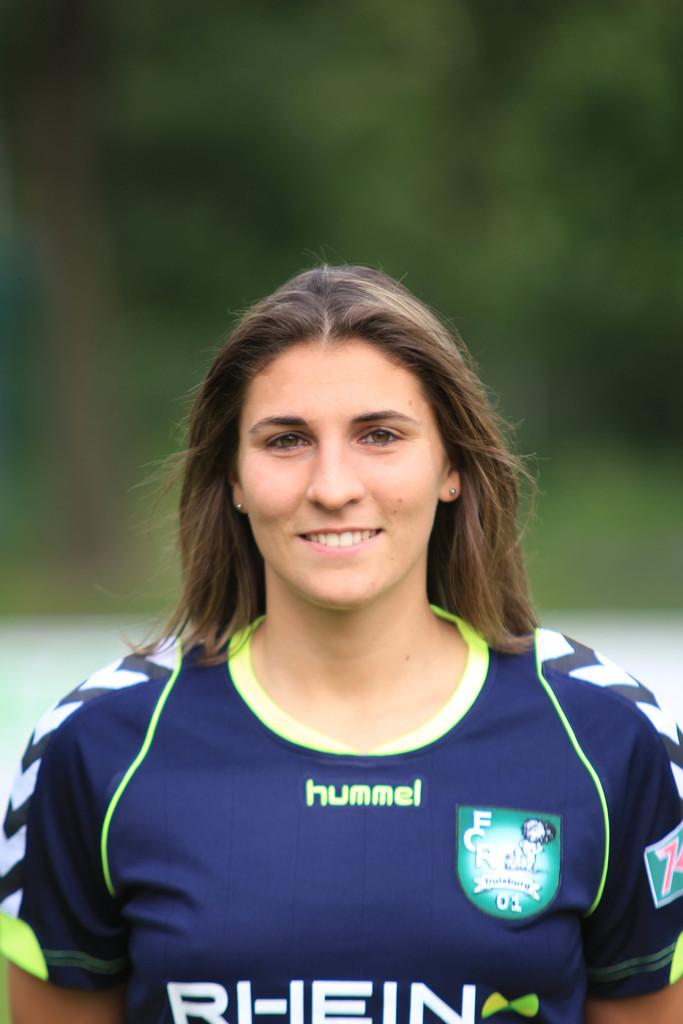Provide a one-sentence caption for the provided image. Woman is wearing a blue and yellow shirt that reads hummel Rhein. 